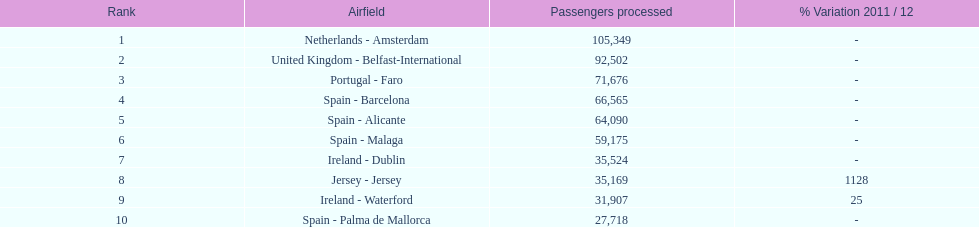Which airport has the least amount of passengers going through london southend airport? Spain - Palma de Mallorca. 